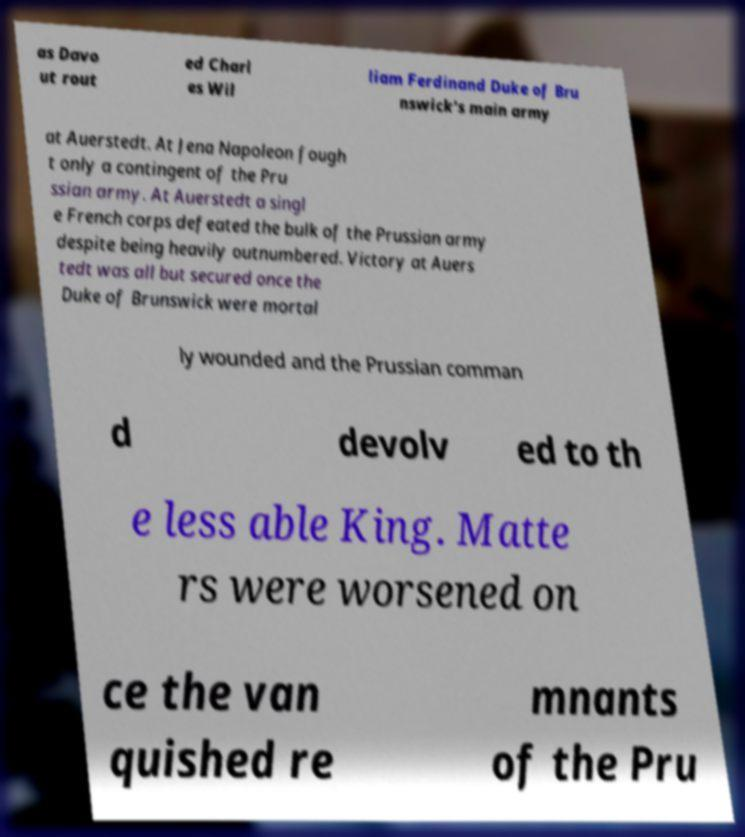Can you read and provide the text displayed in the image?This photo seems to have some interesting text. Can you extract and type it out for me? as Davo ut rout ed Charl es Wil liam Ferdinand Duke of Bru nswick's main army at Auerstedt. At Jena Napoleon fough t only a contingent of the Pru ssian army. At Auerstedt a singl e French corps defeated the bulk of the Prussian army despite being heavily outnumbered. Victory at Auers tedt was all but secured once the Duke of Brunswick were mortal ly wounded and the Prussian comman d devolv ed to th e less able King. Matte rs were worsened on ce the van quished re mnants of the Pru 